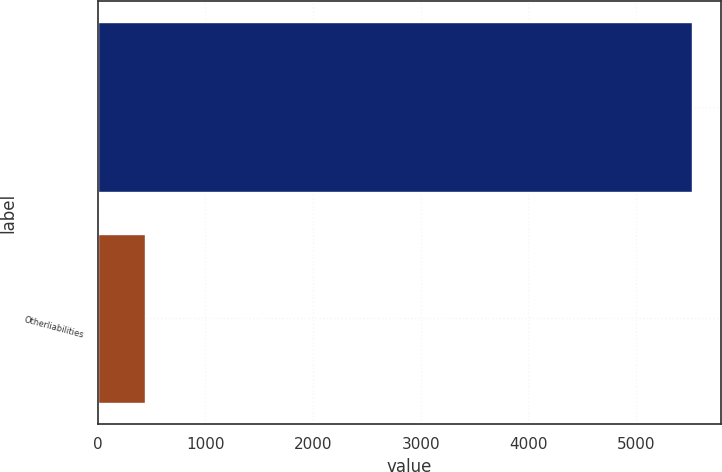Convert chart to OTSL. <chart><loc_0><loc_0><loc_500><loc_500><bar_chart><ecel><fcel>Otherliabilities<nl><fcel>5518<fcel>440<nl></chart> 